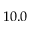<formula> <loc_0><loc_0><loc_500><loc_500>1 0 . 0</formula> 